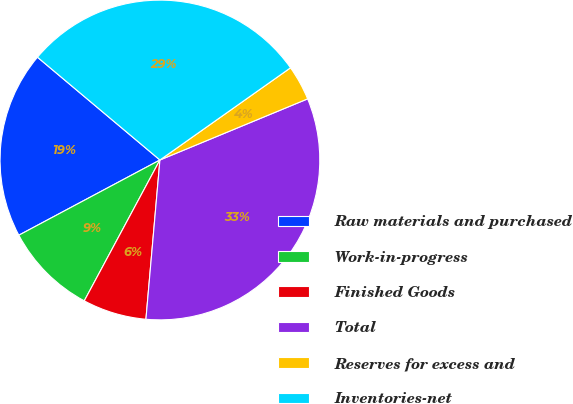Convert chart to OTSL. <chart><loc_0><loc_0><loc_500><loc_500><pie_chart><fcel>Raw materials and purchased<fcel>Work-in-progress<fcel>Finished Goods<fcel>Total<fcel>Reserves for excess and<fcel>Inventories-net<nl><fcel>18.91%<fcel>9.36%<fcel>6.45%<fcel>32.64%<fcel>3.54%<fcel>29.1%<nl></chart> 